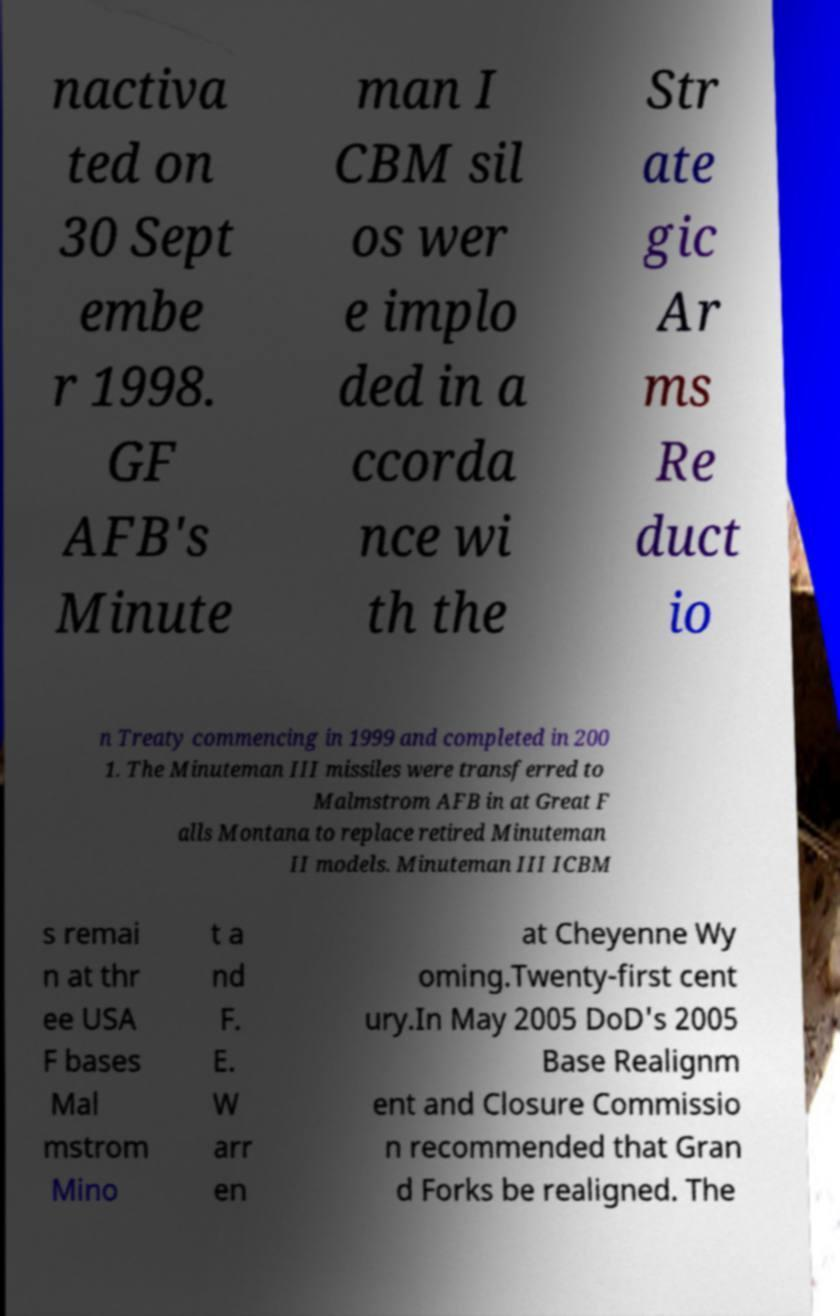Can you read and provide the text displayed in the image?This photo seems to have some interesting text. Can you extract and type it out for me? nactiva ted on 30 Sept embe r 1998. GF AFB's Minute man I CBM sil os wer e implo ded in a ccorda nce wi th the Str ate gic Ar ms Re duct io n Treaty commencing in 1999 and completed in 200 1. The Minuteman III missiles were transferred to Malmstrom AFB in at Great F alls Montana to replace retired Minuteman II models. Minuteman III ICBM s remai n at thr ee USA F bases Mal mstrom Mino t a nd F. E. W arr en at Cheyenne Wy oming.Twenty-first cent ury.In May 2005 DoD's 2005 Base Realignm ent and Closure Commissio n recommended that Gran d Forks be realigned. The 